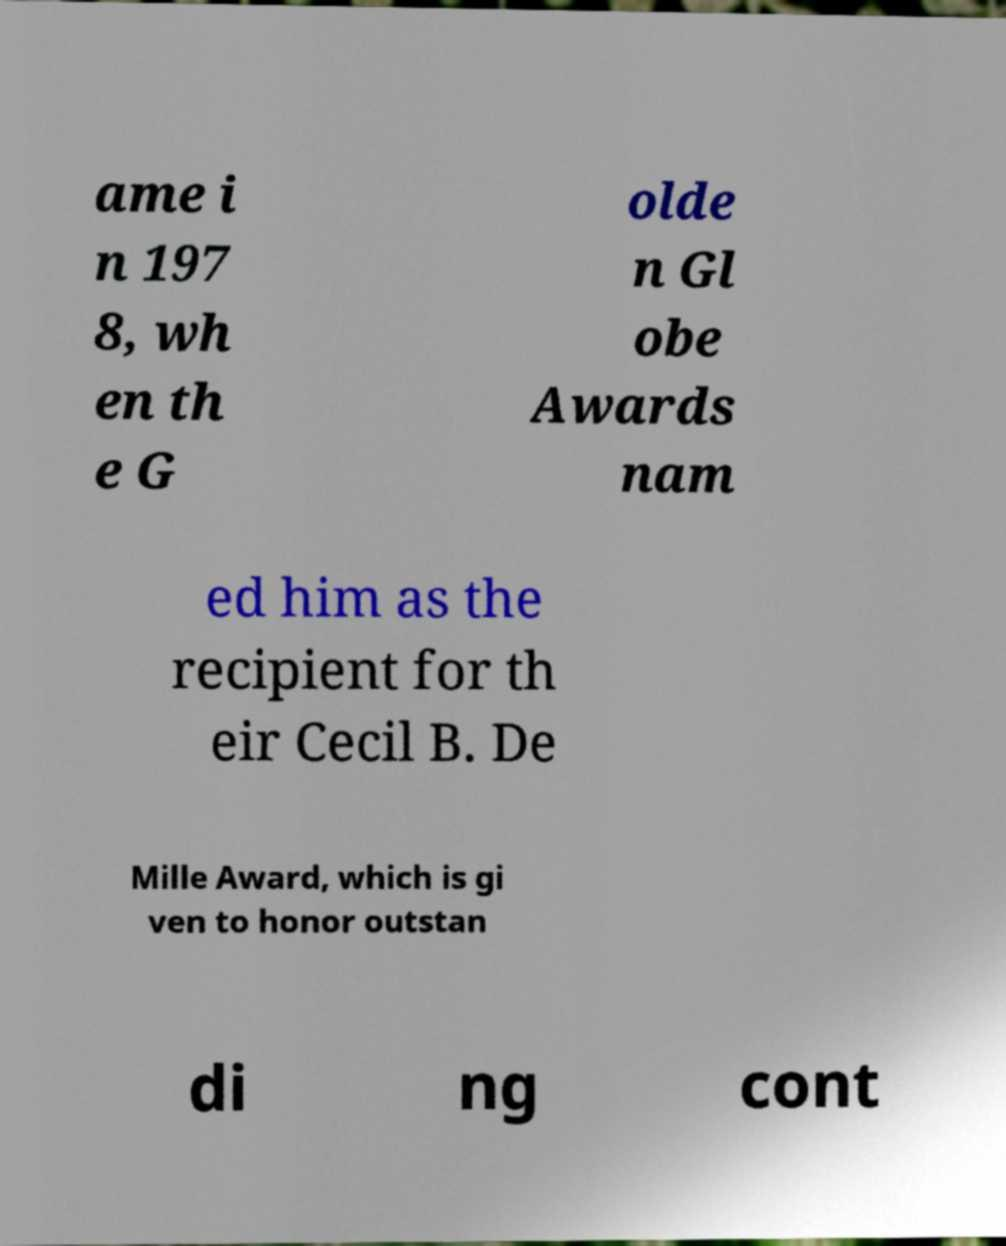Could you assist in decoding the text presented in this image and type it out clearly? ame i n 197 8, wh en th e G olde n Gl obe Awards nam ed him as the recipient for th eir Cecil B. De Mille Award, which is gi ven to honor outstan di ng cont 